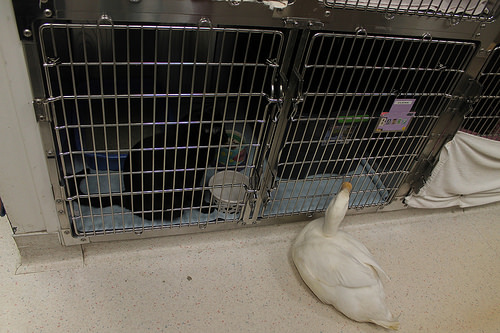<image>
Can you confirm if the duck is next to the cat? Yes. The duck is positioned adjacent to the cat, located nearby in the same general area. 